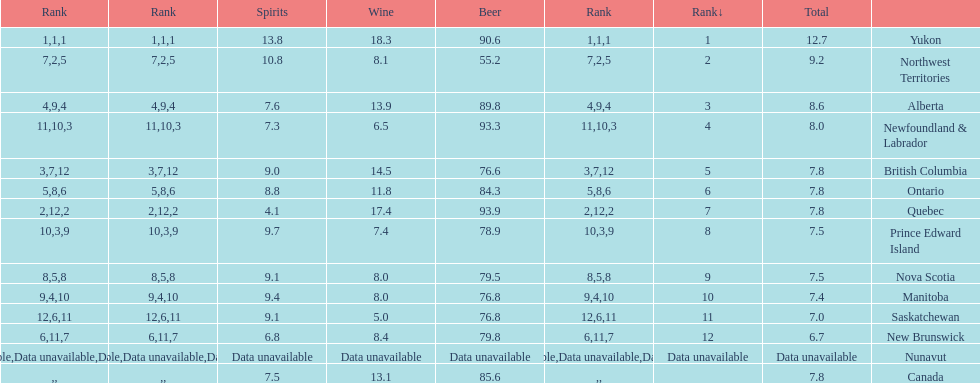Quebuec had a beer consumption of 93.9, what was their spirit consumption? 4.1. 